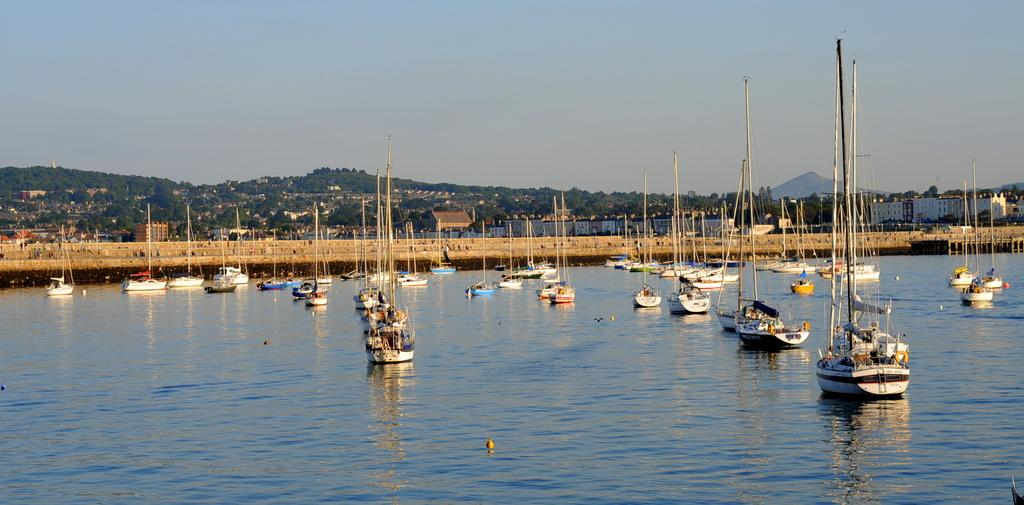What is on the water in the image? There are boats on the water in the image. What else can be seen in the image besides the boats? There are poles in the image. What is visible in the background of the image? There are buildings and trees with green color in the background of the image. What is the color of the sky in the image? The sky is blue in the image. What type of bag is hanging from the ear of the person in the image? There is no person or bag hanging from an ear present in the image. 